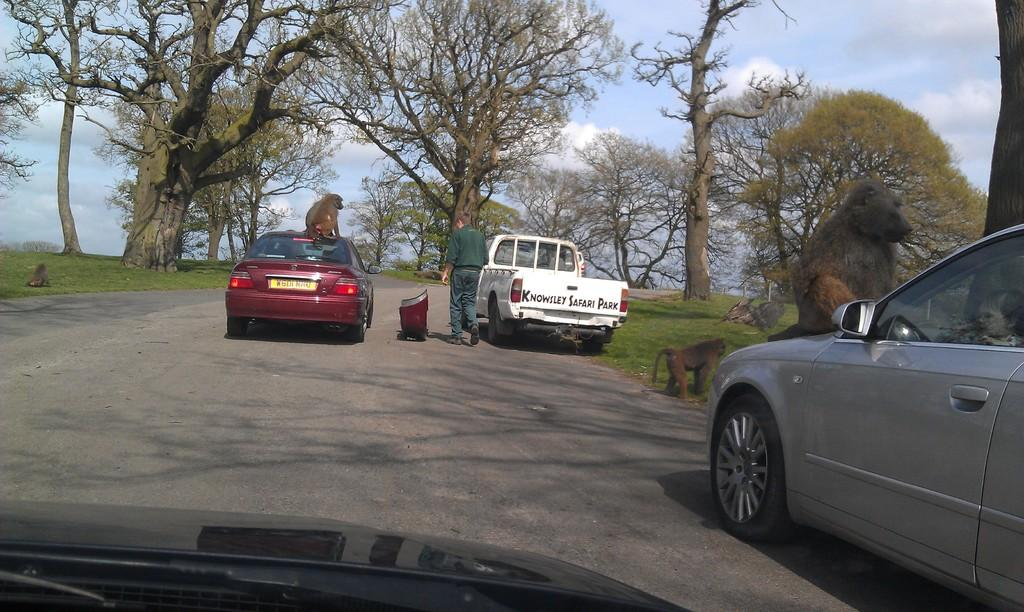What type of vehicles are present in the image? There are cars in the image. What animals are also present in the image? There are monkeys in the image. Where are the monkeys located in relation to the cars? The monkeys are on the cars. Can you describe the person at the center of the image? There is a person at the center of the image. What can be seen in the background of the image? There are trees in the background of the image. What type of powder is being used by the monkeys to draw attention in the image? There is no powder or drawing of attention by the monkeys in the image. 